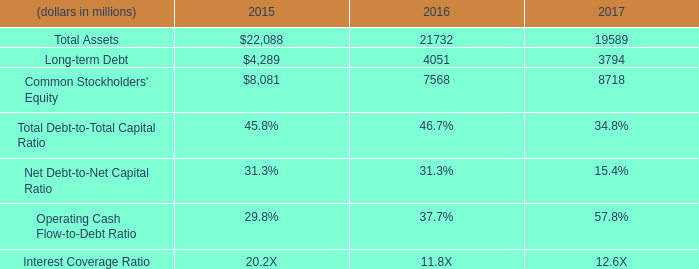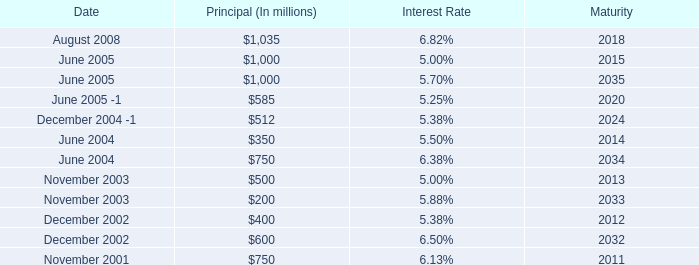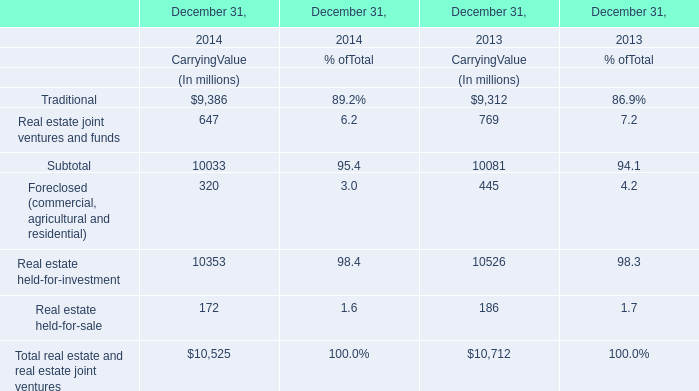What's the growth rate of Real estate held-for-investment at Carrying Value on December 31 in 2014? 
Computations: ((10353 - 10526) / 10526)
Answer: -0.01644. 